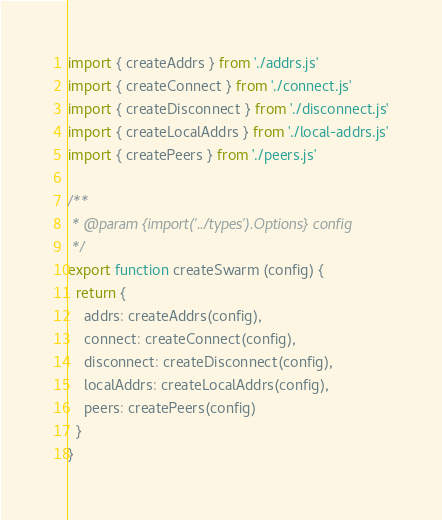Convert code to text. <code><loc_0><loc_0><loc_500><loc_500><_JavaScript_>import { createAddrs } from './addrs.js'
import { createConnect } from './connect.js'
import { createDisconnect } from './disconnect.js'
import { createLocalAddrs } from './local-addrs.js'
import { createPeers } from './peers.js'

/**
 * @param {import('../types').Options} config
 */
export function createSwarm (config) {
  return {
    addrs: createAddrs(config),
    connect: createConnect(config),
    disconnect: createDisconnect(config),
    localAddrs: createLocalAddrs(config),
    peers: createPeers(config)
  }
}
</code> 